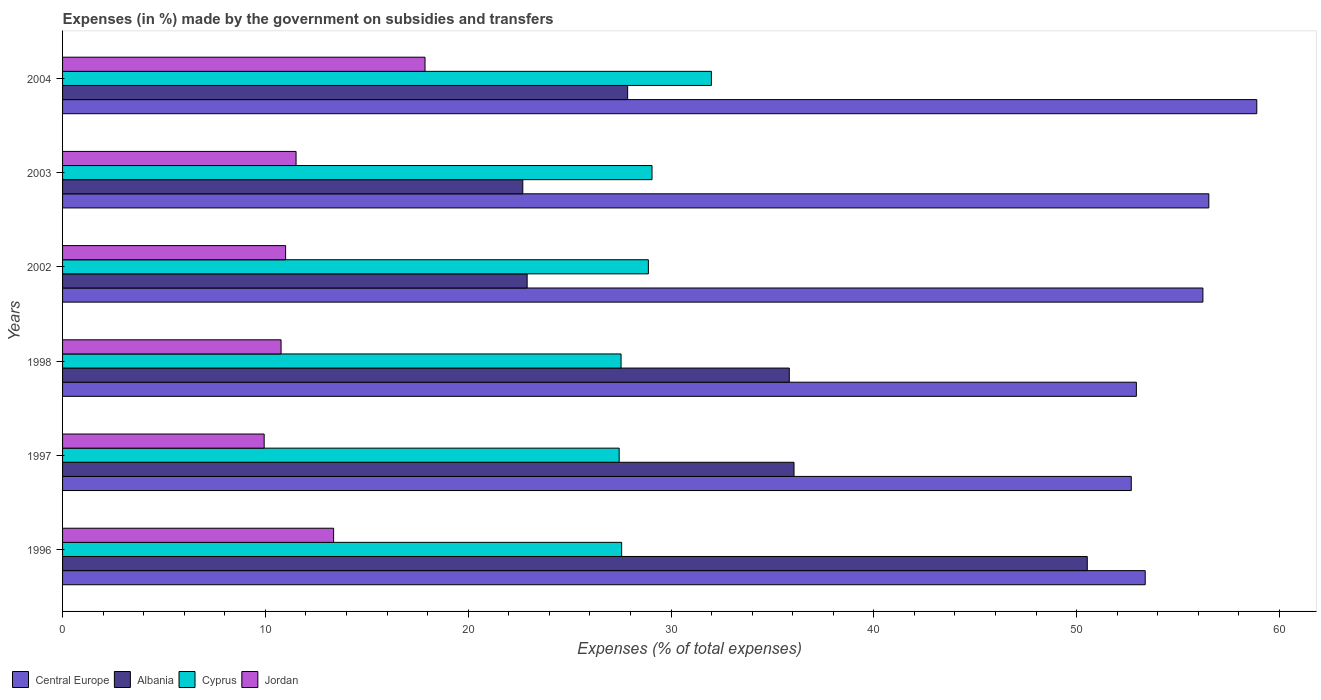How many different coloured bars are there?
Make the answer very short. 4. How many groups of bars are there?
Your answer should be very brief. 6. Are the number of bars on each tick of the Y-axis equal?
Ensure brevity in your answer.  Yes. How many bars are there on the 6th tick from the top?
Make the answer very short. 4. What is the percentage of expenses made by the government on subsidies and transfers in Central Europe in 1996?
Offer a very short reply. 53.38. Across all years, what is the maximum percentage of expenses made by the government on subsidies and transfers in Central Europe?
Make the answer very short. 58.88. Across all years, what is the minimum percentage of expenses made by the government on subsidies and transfers in Central Europe?
Ensure brevity in your answer.  52.69. In which year was the percentage of expenses made by the government on subsidies and transfers in Central Europe minimum?
Make the answer very short. 1997. What is the total percentage of expenses made by the government on subsidies and transfers in Cyprus in the graph?
Ensure brevity in your answer.  172.48. What is the difference between the percentage of expenses made by the government on subsidies and transfers in Albania in 2003 and that in 2004?
Keep it short and to the point. -5.17. What is the difference between the percentage of expenses made by the government on subsidies and transfers in Jordan in 1996 and the percentage of expenses made by the government on subsidies and transfers in Albania in 1997?
Offer a very short reply. -22.7. What is the average percentage of expenses made by the government on subsidies and transfers in Jordan per year?
Your answer should be compact. 12.41. In the year 1998, what is the difference between the percentage of expenses made by the government on subsidies and transfers in Albania and percentage of expenses made by the government on subsidies and transfers in Cyprus?
Offer a terse response. 8.29. In how many years, is the percentage of expenses made by the government on subsidies and transfers in Jordan greater than 54 %?
Keep it short and to the point. 0. What is the ratio of the percentage of expenses made by the government on subsidies and transfers in Jordan in 1996 to that in 1997?
Make the answer very short. 1.34. Is the difference between the percentage of expenses made by the government on subsidies and transfers in Albania in 1996 and 1997 greater than the difference between the percentage of expenses made by the government on subsidies and transfers in Cyprus in 1996 and 1997?
Your response must be concise. Yes. What is the difference between the highest and the second highest percentage of expenses made by the government on subsidies and transfers in Jordan?
Your response must be concise. 4.51. What is the difference between the highest and the lowest percentage of expenses made by the government on subsidies and transfers in Albania?
Keep it short and to the point. 27.83. In how many years, is the percentage of expenses made by the government on subsidies and transfers in Central Europe greater than the average percentage of expenses made by the government on subsidies and transfers in Central Europe taken over all years?
Keep it short and to the point. 3. What does the 1st bar from the top in 2003 represents?
Offer a very short reply. Jordan. What does the 1st bar from the bottom in 1998 represents?
Give a very brief answer. Central Europe. Is it the case that in every year, the sum of the percentage of expenses made by the government on subsidies and transfers in Jordan and percentage of expenses made by the government on subsidies and transfers in Albania is greater than the percentage of expenses made by the government on subsidies and transfers in Central Europe?
Offer a terse response. No. Are all the bars in the graph horizontal?
Provide a succinct answer. Yes. What is the difference between two consecutive major ticks on the X-axis?
Your answer should be very brief. 10. Are the values on the major ticks of X-axis written in scientific E-notation?
Offer a terse response. No. Does the graph contain any zero values?
Provide a short and direct response. No. What is the title of the graph?
Make the answer very short. Expenses (in %) made by the government on subsidies and transfers. What is the label or title of the X-axis?
Make the answer very short. Expenses (% of total expenses). What is the Expenses (% of total expenses) of Central Europe in 1996?
Give a very brief answer. 53.38. What is the Expenses (% of total expenses) in Albania in 1996?
Provide a short and direct response. 50.52. What is the Expenses (% of total expenses) in Cyprus in 1996?
Your answer should be compact. 27.56. What is the Expenses (% of total expenses) of Jordan in 1996?
Provide a succinct answer. 13.36. What is the Expenses (% of total expenses) of Central Europe in 1997?
Your answer should be compact. 52.69. What is the Expenses (% of total expenses) in Albania in 1997?
Keep it short and to the point. 36.06. What is the Expenses (% of total expenses) in Cyprus in 1997?
Your response must be concise. 27.44. What is the Expenses (% of total expenses) in Jordan in 1997?
Keep it short and to the point. 9.94. What is the Expenses (% of total expenses) of Central Europe in 1998?
Your answer should be very brief. 52.94. What is the Expenses (% of total expenses) in Albania in 1998?
Ensure brevity in your answer.  35.83. What is the Expenses (% of total expenses) of Cyprus in 1998?
Ensure brevity in your answer.  27.54. What is the Expenses (% of total expenses) in Jordan in 1998?
Provide a succinct answer. 10.77. What is the Expenses (% of total expenses) of Central Europe in 2002?
Provide a succinct answer. 56.22. What is the Expenses (% of total expenses) in Albania in 2002?
Your answer should be very brief. 22.91. What is the Expenses (% of total expenses) of Cyprus in 2002?
Your response must be concise. 28.88. What is the Expenses (% of total expenses) of Jordan in 2002?
Keep it short and to the point. 11. What is the Expenses (% of total expenses) of Central Europe in 2003?
Your response must be concise. 56.51. What is the Expenses (% of total expenses) in Albania in 2003?
Provide a succinct answer. 22.69. What is the Expenses (% of total expenses) in Cyprus in 2003?
Offer a terse response. 29.06. What is the Expenses (% of total expenses) of Jordan in 2003?
Keep it short and to the point. 11.51. What is the Expenses (% of total expenses) of Central Europe in 2004?
Your answer should be very brief. 58.88. What is the Expenses (% of total expenses) in Albania in 2004?
Give a very brief answer. 27.86. What is the Expenses (% of total expenses) of Cyprus in 2004?
Offer a very short reply. 31.99. What is the Expenses (% of total expenses) of Jordan in 2004?
Provide a short and direct response. 17.87. Across all years, what is the maximum Expenses (% of total expenses) in Central Europe?
Your response must be concise. 58.88. Across all years, what is the maximum Expenses (% of total expenses) of Albania?
Ensure brevity in your answer.  50.52. Across all years, what is the maximum Expenses (% of total expenses) in Cyprus?
Keep it short and to the point. 31.99. Across all years, what is the maximum Expenses (% of total expenses) of Jordan?
Offer a very short reply. 17.87. Across all years, what is the minimum Expenses (% of total expenses) of Central Europe?
Ensure brevity in your answer.  52.69. Across all years, what is the minimum Expenses (% of total expenses) in Albania?
Your response must be concise. 22.69. Across all years, what is the minimum Expenses (% of total expenses) in Cyprus?
Provide a short and direct response. 27.44. Across all years, what is the minimum Expenses (% of total expenses) of Jordan?
Offer a very short reply. 9.94. What is the total Expenses (% of total expenses) in Central Europe in the graph?
Your answer should be very brief. 330.63. What is the total Expenses (% of total expenses) of Albania in the graph?
Offer a terse response. 195.87. What is the total Expenses (% of total expenses) of Cyprus in the graph?
Offer a terse response. 172.48. What is the total Expenses (% of total expenses) in Jordan in the graph?
Provide a short and direct response. 74.46. What is the difference between the Expenses (% of total expenses) of Central Europe in 1996 and that in 1997?
Ensure brevity in your answer.  0.69. What is the difference between the Expenses (% of total expenses) of Albania in 1996 and that in 1997?
Your answer should be compact. 14.46. What is the difference between the Expenses (% of total expenses) of Cyprus in 1996 and that in 1997?
Ensure brevity in your answer.  0.12. What is the difference between the Expenses (% of total expenses) of Jordan in 1996 and that in 1997?
Your answer should be compact. 3.42. What is the difference between the Expenses (% of total expenses) in Central Europe in 1996 and that in 1998?
Give a very brief answer. 0.44. What is the difference between the Expenses (% of total expenses) of Albania in 1996 and that in 1998?
Provide a short and direct response. 14.69. What is the difference between the Expenses (% of total expenses) in Cyprus in 1996 and that in 1998?
Keep it short and to the point. 0.03. What is the difference between the Expenses (% of total expenses) in Jordan in 1996 and that in 1998?
Keep it short and to the point. 2.59. What is the difference between the Expenses (% of total expenses) of Central Europe in 1996 and that in 2002?
Ensure brevity in your answer.  -2.84. What is the difference between the Expenses (% of total expenses) in Albania in 1996 and that in 2002?
Provide a succinct answer. 27.62. What is the difference between the Expenses (% of total expenses) in Cyprus in 1996 and that in 2002?
Offer a terse response. -1.32. What is the difference between the Expenses (% of total expenses) of Jordan in 1996 and that in 2002?
Keep it short and to the point. 2.37. What is the difference between the Expenses (% of total expenses) of Central Europe in 1996 and that in 2003?
Offer a terse response. -3.14. What is the difference between the Expenses (% of total expenses) of Albania in 1996 and that in 2003?
Your answer should be very brief. 27.83. What is the difference between the Expenses (% of total expenses) in Cyprus in 1996 and that in 2003?
Provide a short and direct response. -1.5. What is the difference between the Expenses (% of total expenses) in Jordan in 1996 and that in 2003?
Provide a succinct answer. 1.85. What is the difference between the Expenses (% of total expenses) in Central Europe in 1996 and that in 2004?
Keep it short and to the point. -5.5. What is the difference between the Expenses (% of total expenses) in Albania in 1996 and that in 2004?
Keep it short and to the point. 22.66. What is the difference between the Expenses (% of total expenses) in Cyprus in 1996 and that in 2004?
Your answer should be compact. -4.43. What is the difference between the Expenses (% of total expenses) in Jordan in 1996 and that in 2004?
Make the answer very short. -4.51. What is the difference between the Expenses (% of total expenses) of Central Europe in 1997 and that in 1998?
Your answer should be very brief. -0.25. What is the difference between the Expenses (% of total expenses) in Albania in 1997 and that in 1998?
Provide a short and direct response. 0.23. What is the difference between the Expenses (% of total expenses) in Cyprus in 1997 and that in 1998?
Offer a terse response. -0.09. What is the difference between the Expenses (% of total expenses) in Jordan in 1997 and that in 1998?
Your response must be concise. -0.83. What is the difference between the Expenses (% of total expenses) in Central Europe in 1997 and that in 2002?
Make the answer very short. -3.53. What is the difference between the Expenses (% of total expenses) in Albania in 1997 and that in 2002?
Provide a short and direct response. 13.16. What is the difference between the Expenses (% of total expenses) in Cyprus in 1997 and that in 2002?
Provide a short and direct response. -1.44. What is the difference between the Expenses (% of total expenses) of Jordan in 1997 and that in 2002?
Provide a succinct answer. -1.06. What is the difference between the Expenses (% of total expenses) of Central Europe in 1997 and that in 2003?
Your answer should be very brief. -3.82. What is the difference between the Expenses (% of total expenses) of Albania in 1997 and that in 2003?
Ensure brevity in your answer.  13.37. What is the difference between the Expenses (% of total expenses) in Cyprus in 1997 and that in 2003?
Provide a short and direct response. -1.62. What is the difference between the Expenses (% of total expenses) in Jordan in 1997 and that in 2003?
Give a very brief answer. -1.57. What is the difference between the Expenses (% of total expenses) in Central Europe in 1997 and that in 2004?
Ensure brevity in your answer.  -6.19. What is the difference between the Expenses (% of total expenses) in Albania in 1997 and that in 2004?
Make the answer very short. 8.2. What is the difference between the Expenses (% of total expenses) of Cyprus in 1997 and that in 2004?
Offer a terse response. -4.55. What is the difference between the Expenses (% of total expenses) of Jordan in 1997 and that in 2004?
Your answer should be very brief. -7.93. What is the difference between the Expenses (% of total expenses) of Central Europe in 1998 and that in 2002?
Offer a very short reply. -3.28. What is the difference between the Expenses (% of total expenses) of Albania in 1998 and that in 2002?
Offer a very short reply. 12.92. What is the difference between the Expenses (% of total expenses) in Cyprus in 1998 and that in 2002?
Offer a very short reply. -1.35. What is the difference between the Expenses (% of total expenses) in Jordan in 1998 and that in 2002?
Provide a short and direct response. -0.22. What is the difference between the Expenses (% of total expenses) of Central Europe in 1998 and that in 2003?
Offer a terse response. -3.57. What is the difference between the Expenses (% of total expenses) of Albania in 1998 and that in 2003?
Provide a succinct answer. 13.14. What is the difference between the Expenses (% of total expenses) of Cyprus in 1998 and that in 2003?
Offer a very short reply. -1.53. What is the difference between the Expenses (% of total expenses) of Jordan in 1998 and that in 2003?
Keep it short and to the point. -0.74. What is the difference between the Expenses (% of total expenses) of Central Europe in 1998 and that in 2004?
Provide a short and direct response. -5.94. What is the difference between the Expenses (% of total expenses) of Albania in 1998 and that in 2004?
Make the answer very short. 7.97. What is the difference between the Expenses (% of total expenses) of Cyprus in 1998 and that in 2004?
Give a very brief answer. -4.45. What is the difference between the Expenses (% of total expenses) of Jordan in 1998 and that in 2004?
Make the answer very short. -7.1. What is the difference between the Expenses (% of total expenses) of Central Europe in 2002 and that in 2003?
Your response must be concise. -0.29. What is the difference between the Expenses (% of total expenses) of Albania in 2002 and that in 2003?
Your answer should be very brief. 0.21. What is the difference between the Expenses (% of total expenses) in Cyprus in 2002 and that in 2003?
Make the answer very short. -0.18. What is the difference between the Expenses (% of total expenses) of Jordan in 2002 and that in 2003?
Offer a terse response. -0.52. What is the difference between the Expenses (% of total expenses) in Central Europe in 2002 and that in 2004?
Make the answer very short. -2.66. What is the difference between the Expenses (% of total expenses) in Albania in 2002 and that in 2004?
Your answer should be very brief. -4.96. What is the difference between the Expenses (% of total expenses) of Cyprus in 2002 and that in 2004?
Your response must be concise. -3.11. What is the difference between the Expenses (% of total expenses) in Jordan in 2002 and that in 2004?
Your answer should be very brief. -6.87. What is the difference between the Expenses (% of total expenses) in Central Europe in 2003 and that in 2004?
Keep it short and to the point. -2.36. What is the difference between the Expenses (% of total expenses) in Albania in 2003 and that in 2004?
Keep it short and to the point. -5.17. What is the difference between the Expenses (% of total expenses) of Cyprus in 2003 and that in 2004?
Provide a short and direct response. -2.93. What is the difference between the Expenses (% of total expenses) of Jordan in 2003 and that in 2004?
Your response must be concise. -6.36. What is the difference between the Expenses (% of total expenses) in Central Europe in 1996 and the Expenses (% of total expenses) in Albania in 1997?
Provide a short and direct response. 17.32. What is the difference between the Expenses (% of total expenses) in Central Europe in 1996 and the Expenses (% of total expenses) in Cyprus in 1997?
Give a very brief answer. 25.94. What is the difference between the Expenses (% of total expenses) of Central Europe in 1996 and the Expenses (% of total expenses) of Jordan in 1997?
Give a very brief answer. 43.44. What is the difference between the Expenses (% of total expenses) of Albania in 1996 and the Expenses (% of total expenses) of Cyprus in 1997?
Provide a succinct answer. 23.08. What is the difference between the Expenses (% of total expenses) in Albania in 1996 and the Expenses (% of total expenses) in Jordan in 1997?
Make the answer very short. 40.58. What is the difference between the Expenses (% of total expenses) of Cyprus in 1996 and the Expenses (% of total expenses) of Jordan in 1997?
Provide a succinct answer. 17.62. What is the difference between the Expenses (% of total expenses) in Central Europe in 1996 and the Expenses (% of total expenses) in Albania in 1998?
Provide a short and direct response. 17.55. What is the difference between the Expenses (% of total expenses) of Central Europe in 1996 and the Expenses (% of total expenses) of Cyprus in 1998?
Provide a short and direct response. 25.84. What is the difference between the Expenses (% of total expenses) of Central Europe in 1996 and the Expenses (% of total expenses) of Jordan in 1998?
Give a very brief answer. 42.61. What is the difference between the Expenses (% of total expenses) in Albania in 1996 and the Expenses (% of total expenses) in Cyprus in 1998?
Offer a terse response. 22.99. What is the difference between the Expenses (% of total expenses) in Albania in 1996 and the Expenses (% of total expenses) in Jordan in 1998?
Your response must be concise. 39.75. What is the difference between the Expenses (% of total expenses) in Cyprus in 1996 and the Expenses (% of total expenses) in Jordan in 1998?
Provide a short and direct response. 16.79. What is the difference between the Expenses (% of total expenses) of Central Europe in 1996 and the Expenses (% of total expenses) of Albania in 2002?
Ensure brevity in your answer.  30.47. What is the difference between the Expenses (% of total expenses) of Central Europe in 1996 and the Expenses (% of total expenses) of Cyprus in 2002?
Provide a short and direct response. 24.5. What is the difference between the Expenses (% of total expenses) in Central Europe in 1996 and the Expenses (% of total expenses) in Jordan in 2002?
Your answer should be very brief. 42.38. What is the difference between the Expenses (% of total expenses) in Albania in 1996 and the Expenses (% of total expenses) in Cyprus in 2002?
Make the answer very short. 21.64. What is the difference between the Expenses (% of total expenses) in Albania in 1996 and the Expenses (% of total expenses) in Jordan in 2002?
Give a very brief answer. 39.53. What is the difference between the Expenses (% of total expenses) in Cyprus in 1996 and the Expenses (% of total expenses) in Jordan in 2002?
Your answer should be compact. 16.57. What is the difference between the Expenses (% of total expenses) of Central Europe in 1996 and the Expenses (% of total expenses) of Albania in 2003?
Your response must be concise. 30.69. What is the difference between the Expenses (% of total expenses) of Central Europe in 1996 and the Expenses (% of total expenses) of Cyprus in 2003?
Your answer should be very brief. 24.32. What is the difference between the Expenses (% of total expenses) in Central Europe in 1996 and the Expenses (% of total expenses) in Jordan in 2003?
Your answer should be compact. 41.87. What is the difference between the Expenses (% of total expenses) of Albania in 1996 and the Expenses (% of total expenses) of Cyprus in 2003?
Provide a short and direct response. 21.46. What is the difference between the Expenses (% of total expenses) in Albania in 1996 and the Expenses (% of total expenses) in Jordan in 2003?
Provide a succinct answer. 39.01. What is the difference between the Expenses (% of total expenses) of Cyprus in 1996 and the Expenses (% of total expenses) of Jordan in 2003?
Provide a short and direct response. 16.05. What is the difference between the Expenses (% of total expenses) of Central Europe in 1996 and the Expenses (% of total expenses) of Albania in 2004?
Keep it short and to the point. 25.52. What is the difference between the Expenses (% of total expenses) of Central Europe in 1996 and the Expenses (% of total expenses) of Cyprus in 2004?
Keep it short and to the point. 21.39. What is the difference between the Expenses (% of total expenses) in Central Europe in 1996 and the Expenses (% of total expenses) in Jordan in 2004?
Your answer should be very brief. 35.51. What is the difference between the Expenses (% of total expenses) in Albania in 1996 and the Expenses (% of total expenses) in Cyprus in 2004?
Ensure brevity in your answer.  18.53. What is the difference between the Expenses (% of total expenses) of Albania in 1996 and the Expenses (% of total expenses) of Jordan in 2004?
Give a very brief answer. 32.65. What is the difference between the Expenses (% of total expenses) in Cyprus in 1996 and the Expenses (% of total expenses) in Jordan in 2004?
Your answer should be very brief. 9.69. What is the difference between the Expenses (% of total expenses) in Central Europe in 1997 and the Expenses (% of total expenses) in Albania in 1998?
Your answer should be very brief. 16.86. What is the difference between the Expenses (% of total expenses) of Central Europe in 1997 and the Expenses (% of total expenses) of Cyprus in 1998?
Offer a very short reply. 25.16. What is the difference between the Expenses (% of total expenses) in Central Europe in 1997 and the Expenses (% of total expenses) in Jordan in 1998?
Ensure brevity in your answer.  41.92. What is the difference between the Expenses (% of total expenses) in Albania in 1997 and the Expenses (% of total expenses) in Cyprus in 1998?
Keep it short and to the point. 8.53. What is the difference between the Expenses (% of total expenses) of Albania in 1997 and the Expenses (% of total expenses) of Jordan in 1998?
Make the answer very short. 25.29. What is the difference between the Expenses (% of total expenses) of Cyprus in 1997 and the Expenses (% of total expenses) of Jordan in 1998?
Provide a succinct answer. 16.67. What is the difference between the Expenses (% of total expenses) of Central Europe in 1997 and the Expenses (% of total expenses) of Albania in 2002?
Offer a very short reply. 29.79. What is the difference between the Expenses (% of total expenses) in Central Europe in 1997 and the Expenses (% of total expenses) in Cyprus in 2002?
Provide a succinct answer. 23.81. What is the difference between the Expenses (% of total expenses) of Central Europe in 1997 and the Expenses (% of total expenses) of Jordan in 2002?
Your answer should be compact. 41.69. What is the difference between the Expenses (% of total expenses) in Albania in 1997 and the Expenses (% of total expenses) in Cyprus in 2002?
Keep it short and to the point. 7.18. What is the difference between the Expenses (% of total expenses) in Albania in 1997 and the Expenses (% of total expenses) in Jordan in 2002?
Provide a short and direct response. 25.07. What is the difference between the Expenses (% of total expenses) in Cyprus in 1997 and the Expenses (% of total expenses) in Jordan in 2002?
Ensure brevity in your answer.  16.45. What is the difference between the Expenses (% of total expenses) in Central Europe in 1997 and the Expenses (% of total expenses) in Albania in 2003?
Provide a succinct answer. 30. What is the difference between the Expenses (% of total expenses) of Central Europe in 1997 and the Expenses (% of total expenses) of Cyprus in 2003?
Offer a very short reply. 23.63. What is the difference between the Expenses (% of total expenses) in Central Europe in 1997 and the Expenses (% of total expenses) in Jordan in 2003?
Offer a terse response. 41.18. What is the difference between the Expenses (% of total expenses) in Albania in 1997 and the Expenses (% of total expenses) in Cyprus in 2003?
Give a very brief answer. 7. What is the difference between the Expenses (% of total expenses) of Albania in 1997 and the Expenses (% of total expenses) of Jordan in 2003?
Your response must be concise. 24.55. What is the difference between the Expenses (% of total expenses) of Cyprus in 1997 and the Expenses (% of total expenses) of Jordan in 2003?
Ensure brevity in your answer.  15.93. What is the difference between the Expenses (% of total expenses) of Central Europe in 1997 and the Expenses (% of total expenses) of Albania in 2004?
Make the answer very short. 24.83. What is the difference between the Expenses (% of total expenses) of Central Europe in 1997 and the Expenses (% of total expenses) of Cyprus in 2004?
Offer a very short reply. 20.7. What is the difference between the Expenses (% of total expenses) in Central Europe in 1997 and the Expenses (% of total expenses) in Jordan in 2004?
Your response must be concise. 34.82. What is the difference between the Expenses (% of total expenses) in Albania in 1997 and the Expenses (% of total expenses) in Cyprus in 2004?
Offer a terse response. 4.07. What is the difference between the Expenses (% of total expenses) of Albania in 1997 and the Expenses (% of total expenses) of Jordan in 2004?
Keep it short and to the point. 18.19. What is the difference between the Expenses (% of total expenses) in Cyprus in 1997 and the Expenses (% of total expenses) in Jordan in 2004?
Your answer should be very brief. 9.57. What is the difference between the Expenses (% of total expenses) in Central Europe in 1998 and the Expenses (% of total expenses) in Albania in 2002?
Offer a terse response. 30.04. What is the difference between the Expenses (% of total expenses) of Central Europe in 1998 and the Expenses (% of total expenses) of Cyprus in 2002?
Keep it short and to the point. 24.06. What is the difference between the Expenses (% of total expenses) in Central Europe in 1998 and the Expenses (% of total expenses) in Jordan in 2002?
Ensure brevity in your answer.  41.95. What is the difference between the Expenses (% of total expenses) in Albania in 1998 and the Expenses (% of total expenses) in Cyprus in 2002?
Keep it short and to the point. 6.95. What is the difference between the Expenses (% of total expenses) of Albania in 1998 and the Expenses (% of total expenses) of Jordan in 2002?
Make the answer very short. 24.83. What is the difference between the Expenses (% of total expenses) of Cyprus in 1998 and the Expenses (% of total expenses) of Jordan in 2002?
Provide a short and direct response. 16.54. What is the difference between the Expenses (% of total expenses) in Central Europe in 1998 and the Expenses (% of total expenses) in Albania in 2003?
Your answer should be compact. 30.25. What is the difference between the Expenses (% of total expenses) of Central Europe in 1998 and the Expenses (% of total expenses) of Cyprus in 2003?
Your answer should be compact. 23.88. What is the difference between the Expenses (% of total expenses) in Central Europe in 1998 and the Expenses (% of total expenses) in Jordan in 2003?
Your response must be concise. 41.43. What is the difference between the Expenses (% of total expenses) in Albania in 1998 and the Expenses (% of total expenses) in Cyprus in 2003?
Your answer should be very brief. 6.77. What is the difference between the Expenses (% of total expenses) in Albania in 1998 and the Expenses (% of total expenses) in Jordan in 2003?
Offer a terse response. 24.32. What is the difference between the Expenses (% of total expenses) in Cyprus in 1998 and the Expenses (% of total expenses) in Jordan in 2003?
Make the answer very short. 16.02. What is the difference between the Expenses (% of total expenses) in Central Europe in 1998 and the Expenses (% of total expenses) in Albania in 2004?
Ensure brevity in your answer.  25.08. What is the difference between the Expenses (% of total expenses) of Central Europe in 1998 and the Expenses (% of total expenses) of Cyprus in 2004?
Your answer should be very brief. 20.95. What is the difference between the Expenses (% of total expenses) of Central Europe in 1998 and the Expenses (% of total expenses) of Jordan in 2004?
Make the answer very short. 35.07. What is the difference between the Expenses (% of total expenses) in Albania in 1998 and the Expenses (% of total expenses) in Cyprus in 2004?
Offer a terse response. 3.84. What is the difference between the Expenses (% of total expenses) in Albania in 1998 and the Expenses (% of total expenses) in Jordan in 2004?
Your answer should be very brief. 17.96. What is the difference between the Expenses (% of total expenses) of Cyprus in 1998 and the Expenses (% of total expenses) of Jordan in 2004?
Keep it short and to the point. 9.66. What is the difference between the Expenses (% of total expenses) in Central Europe in 2002 and the Expenses (% of total expenses) in Albania in 2003?
Give a very brief answer. 33.53. What is the difference between the Expenses (% of total expenses) of Central Europe in 2002 and the Expenses (% of total expenses) of Cyprus in 2003?
Offer a terse response. 27.16. What is the difference between the Expenses (% of total expenses) of Central Europe in 2002 and the Expenses (% of total expenses) of Jordan in 2003?
Keep it short and to the point. 44.71. What is the difference between the Expenses (% of total expenses) in Albania in 2002 and the Expenses (% of total expenses) in Cyprus in 2003?
Ensure brevity in your answer.  -6.16. What is the difference between the Expenses (% of total expenses) of Albania in 2002 and the Expenses (% of total expenses) of Jordan in 2003?
Your answer should be compact. 11.39. What is the difference between the Expenses (% of total expenses) in Cyprus in 2002 and the Expenses (% of total expenses) in Jordan in 2003?
Your answer should be compact. 17.37. What is the difference between the Expenses (% of total expenses) in Central Europe in 2002 and the Expenses (% of total expenses) in Albania in 2004?
Your response must be concise. 28.36. What is the difference between the Expenses (% of total expenses) of Central Europe in 2002 and the Expenses (% of total expenses) of Cyprus in 2004?
Provide a short and direct response. 24.23. What is the difference between the Expenses (% of total expenses) of Central Europe in 2002 and the Expenses (% of total expenses) of Jordan in 2004?
Ensure brevity in your answer.  38.35. What is the difference between the Expenses (% of total expenses) in Albania in 2002 and the Expenses (% of total expenses) in Cyprus in 2004?
Ensure brevity in your answer.  -9.08. What is the difference between the Expenses (% of total expenses) of Albania in 2002 and the Expenses (% of total expenses) of Jordan in 2004?
Your response must be concise. 5.03. What is the difference between the Expenses (% of total expenses) of Cyprus in 2002 and the Expenses (% of total expenses) of Jordan in 2004?
Make the answer very short. 11.01. What is the difference between the Expenses (% of total expenses) in Central Europe in 2003 and the Expenses (% of total expenses) in Albania in 2004?
Offer a terse response. 28.65. What is the difference between the Expenses (% of total expenses) in Central Europe in 2003 and the Expenses (% of total expenses) in Cyprus in 2004?
Make the answer very short. 24.52. What is the difference between the Expenses (% of total expenses) of Central Europe in 2003 and the Expenses (% of total expenses) of Jordan in 2004?
Make the answer very short. 38.64. What is the difference between the Expenses (% of total expenses) of Albania in 2003 and the Expenses (% of total expenses) of Cyprus in 2004?
Your answer should be compact. -9.3. What is the difference between the Expenses (% of total expenses) in Albania in 2003 and the Expenses (% of total expenses) in Jordan in 2004?
Your answer should be very brief. 4.82. What is the difference between the Expenses (% of total expenses) of Cyprus in 2003 and the Expenses (% of total expenses) of Jordan in 2004?
Your answer should be compact. 11.19. What is the average Expenses (% of total expenses) in Central Europe per year?
Make the answer very short. 55.11. What is the average Expenses (% of total expenses) of Albania per year?
Offer a very short reply. 32.65. What is the average Expenses (% of total expenses) in Cyprus per year?
Keep it short and to the point. 28.75. What is the average Expenses (% of total expenses) in Jordan per year?
Keep it short and to the point. 12.41. In the year 1996, what is the difference between the Expenses (% of total expenses) of Central Europe and Expenses (% of total expenses) of Albania?
Offer a terse response. 2.86. In the year 1996, what is the difference between the Expenses (% of total expenses) of Central Europe and Expenses (% of total expenses) of Cyprus?
Offer a terse response. 25.81. In the year 1996, what is the difference between the Expenses (% of total expenses) in Central Europe and Expenses (% of total expenses) in Jordan?
Offer a very short reply. 40.02. In the year 1996, what is the difference between the Expenses (% of total expenses) of Albania and Expenses (% of total expenses) of Cyprus?
Your answer should be compact. 22.96. In the year 1996, what is the difference between the Expenses (% of total expenses) in Albania and Expenses (% of total expenses) in Jordan?
Offer a terse response. 37.16. In the year 1996, what is the difference between the Expenses (% of total expenses) in Cyprus and Expenses (% of total expenses) in Jordan?
Offer a terse response. 14.2. In the year 1997, what is the difference between the Expenses (% of total expenses) of Central Europe and Expenses (% of total expenses) of Albania?
Keep it short and to the point. 16.63. In the year 1997, what is the difference between the Expenses (% of total expenses) in Central Europe and Expenses (% of total expenses) in Cyprus?
Your answer should be very brief. 25.25. In the year 1997, what is the difference between the Expenses (% of total expenses) of Central Europe and Expenses (% of total expenses) of Jordan?
Your answer should be very brief. 42.75. In the year 1997, what is the difference between the Expenses (% of total expenses) of Albania and Expenses (% of total expenses) of Cyprus?
Provide a short and direct response. 8.62. In the year 1997, what is the difference between the Expenses (% of total expenses) in Albania and Expenses (% of total expenses) in Jordan?
Offer a very short reply. 26.12. In the year 1997, what is the difference between the Expenses (% of total expenses) in Cyprus and Expenses (% of total expenses) in Jordan?
Ensure brevity in your answer.  17.5. In the year 1998, what is the difference between the Expenses (% of total expenses) in Central Europe and Expenses (% of total expenses) in Albania?
Your answer should be very brief. 17.11. In the year 1998, what is the difference between the Expenses (% of total expenses) in Central Europe and Expenses (% of total expenses) in Cyprus?
Give a very brief answer. 25.41. In the year 1998, what is the difference between the Expenses (% of total expenses) in Central Europe and Expenses (% of total expenses) in Jordan?
Ensure brevity in your answer.  42.17. In the year 1998, what is the difference between the Expenses (% of total expenses) of Albania and Expenses (% of total expenses) of Cyprus?
Ensure brevity in your answer.  8.29. In the year 1998, what is the difference between the Expenses (% of total expenses) of Albania and Expenses (% of total expenses) of Jordan?
Provide a succinct answer. 25.06. In the year 1998, what is the difference between the Expenses (% of total expenses) of Cyprus and Expenses (% of total expenses) of Jordan?
Your response must be concise. 16.76. In the year 2002, what is the difference between the Expenses (% of total expenses) in Central Europe and Expenses (% of total expenses) in Albania?
Keep it short and to the point. 33.32. In the year 2002, what is the difference between the Expenses (% of total expenses) in Central Europe and Expenses (% of total expenses) in Cyprus?
Offer a terse response. 27.34. In the year 2002, what is the difference between the Expenses (% of total expenses) of Central Europe and Expenses (% of total expenses) of Jordan?
Give a very brief answer. 45.23. In the year 2002, what is the difference between the Expenses (% of total expenses) of Albania and Expenses (% of total expenses) of Cyprus?
Give a very brief answer. -5.98. In the year 2002, what is the difference between the Expenses (% of total expenses) in Albania and Expenses (% of total expenses) in Jordan?
Ensure brevity in your answer.  11.91. In the year 2002, what is the difference between the Expenses (% of total expenses) in Cyprus and Expenses (% of total expenses) in Jordan?
Provide a succinct answer. 17.89. In the year 2003, what is the difference between the Expenses (% of total expenses) in Central Europe and Expenses (% of total expenses) in Albania?
Offer a very short reply. 33.82. In the year 2003, what is the difference between the Expenses (% of total expenses) in Central Europe and Expenses (% of total expenses) in Cyprus?
Provide a succinct answer. 27.45. In the year 2003, what is the difference between the Expenses (% of total expenses) of Central Europe and Expenses (% of total expenses) of Jordan?
Your answer should be compact. 45. In the year 2003, what is the difference between the Expenses (% of total expenses) of Albania and Expenses (% of total expenses) of Cyprus?
Offer a terse response. -6.37. In the year 2003, what is the difference between the Expenses (% of total expenses) of Albania and Expenses (% of total expenses) of Jordan?
Your answer should be very brief. 11.18. In the year 2003, what is the difference between the Expenses (% of total expenses) of Cyprus and Expenses (% of total expenses) of Jordan?
Offer a very short reply. 17.55. In the year 2004, what is the difference between the Expenses (% of total expenses) of Central Europe and Expenses (% of total expenses) of Albania?
Offer a terse response. 31.02. In the year 2004, what is the difference between the Expenses (% of total expenses) of Central Europe and Expenses (% of total expenses) of Cyprus?
Your answer should be very brief. 26.89. In the year 2004, what is the difference between the Expenses (% of total expenses) of Central Europe and Expenses (% of total expenses) of Jordan?
Your response must be concise. 41.01. In the year 2004, what is the difference between the Expenses (% of total expenses) of Albania and Expenses (% of total expenses) of Cyprus?
Make the answer very short. -4.13. In the year 2004, what is the difference between the Expenses (% of total expenses) of Albania and Expenses (% of total expenses) of Jordan?
Keep it short and to the point. 9.99. In the year 2004, what is the difference between the Expenses (% of total expenses) of Cyprus and Expenses (% of total expenses) of Jordan?
Keep it short and to the point. 14.12. What is the ratio of the Expenses (% of total expenses) in Albania in 1996 to that in 1997?
Provide a succinct answer. 1.4. What is the ratio of the Expenses (% of total expenses) of Jordan in 1996 to that in 1997?
Make the answer very short. 1.34. What is the ratio of the Expenses (% of total expenses) in Central Europe in 1996 to that in 1998?
Offer a terse response. 1.01. What is the ratio of the Expenses (% of total expenses) in Albania in 1996 to that in 1998?
Your answer should be very brief. 1.41. What is the ratio of the Expenses (% of total expenses) in Jordan in 1996 to that in 1998?
Your answer should be very brief. 1.24. What is the ratio of the Expenses (% of total expenses) in Central Europe in 1996 to that in 2002?
Provide a short and direct response. 0.95. What is the ratio of the Expenses (% of total expenses) in Albania in 1996 to that in 2002?
Offer a very short reply. 2.21. What is the ratio of the Expenses (% of total expenses) of Cyprus in 1996 to that in 2002?
Keep it short and to the point. 0.95. What is the ratio of the Expenses (% of total expenses) of Jordan in 1996 to that in 2002?
Your answer should be compact. 1.22. What is the ratio of the Expenses (% of total expenses) of Central Europe in 1996 to that in 2003?
Offer a very short reply. 0.94. What is the ratio of the Expenses (% of total expenses) in Albania in 1996 to that in 2003?
Your answer should be very brief. 2.23. What is the ratio of the Expenses (% of total expenses) of Cyprus in 1996 to that in 2003?
Give a very brief answer. 0.95. What is the ratio of the Expenses (% of total expenses) in Jordan in 1996 to that in 2003?
Ensure brevity in your answer.  1.16. What is the ratio of the Expenses (% of total expenses) of Central Europe in 1996 to that in 2004?
Offer a very short reply. 0.91. What is the ratio of the Expenses (% of total expenses) of Albania in 1996 to that in 2004?
Offer a terse response. 1.81. What is the ratio of the Expenses (% of total expenses) in Cyprus in 1996 to that in 2004?
Keep it short and to the point. 0.86. What is the ratio of the Expenses (% of total expenses) of Jordan in 1996 to that in 2004?
Your answer should be very brief. 0.75. What is the ratio of the Expenses (% of total expenses) of Central Europe in 1997 to that in 1998?
Give a very brief answer. 1. What is the ratio of the Expenses (% of total expenses) of Albania in 1997 to that in 1998?
Ensure brevity in your answer.  1.01. What is the ratio of the Expenses (% of total expenses) in Cyprus in 1997 to that in 1998?
Offer a very short reply. 1. What is the ratio of the Expenses (% of total expenses) of Jordan in 1997 to that in 1998?
Provide a succinct answer. 0.92. What is the ratio of the Expenses (% of total expenses) in Central Europe in 1997 to that in 2002?
Provide a short and direct response. 0.94. What is the ratio of the Expenses (% of total expenses) of Albania in 1997 to that in 2002?
Provide a short and direct response. 1.57. What is the ratio of the Expenses (% of total expenses) in Cyprus in 1997 to that in 2002?
Your response must be concise. 0.95. What is the ratio of the Expenses (% of total expenses) in Jordan in 1997 to that in 2002?
Offer a very short reply. 0.9. What is the ratio of the Expenses (% of total expenses) of Central Europe in 1997 to that in 2003?
Keep it short and to the point. 0.93. What is the ratio of the Expenses (% of total expenses) in Albania in 1997 to that in 2003?
Offer a terse response. 1.59. What is the ratio of the Expenses (% of total expenses) in Cyprus in 1997 to that in 2003?
Provide a short and direct response. 0.94. What is the ratio of the Expenses (% of total expenses) of Jordan in 1997 to that in 2003?
Make the answer very short. 0.86. What is the ratio of the Expenses (% of total expenses) in Central Europe in 1997 to that in 2004?
Give a very brief answer. 0.89. What is the ratio of the Expenses (% of total expenses) in Albania in 1997 to that in 2004?
Make the answer very short. 1.29. What is the ratio of the Expenses (% of total expenses) of Cyprus in 1997 to that in 2004?
Keep it short and to the point. 0.86. What is the ratio of the Expenses (% of total expenses) in Jordan in 1997 to that in 2004?
Keep it short and to the point. 0.56. What is the ratio of the Expenses (% of total expenses) in Central Europe in 1998 to that in 2002?
Ensure brevity in your answer.  0.94. What is the ratio of the Expenses (% of total expenses) of Albania in 1998 to that in 2002?
Your answer should be compact. 1.56. What is the ratio of the Expenses (% of total expenses) of Cyprus in 1998 to that in 2002?
Ensure brevity in your answer.  0.95. What is the ratio of the Expenses (% of total expenses) of Jordan in 1998 to that in 2002?
Give a very brief answer. 0.98. What is the ratio of the Expenses (% of total expenses) of Central Europe in 1998 to that in 2003?
Offer a very short reply. 0.94. What is the ratio of the Expenses (% of total expenses) in Albania in 1998 to that in 2003?
Keep it short and to the point. 1.58. What is the ratio of the Expenses (% of total expenses) of Cyprus in 1998 to that in 2003?
Your response must be concise. 0.95. What is the ratio of the Expenses (% of total expenses) in Jordan in 1998 to that in 2003?
Your response must be concise. 0.94. What is the ratio of the Expenses (% of total expenses) in Central Europe in 1998 to that in 2004?
Your response must be concise. 0.9. What is the ratio of the Expenses (% of total expenses) in Albania in 1998 to that in 2004?
Make the answer very short. 1.29. What is the ratio of the Expenses (% of total expenses) in Cyprus in 1998 to that in 2004?
Offer a terse response. 0.86. What is the ratio of the Expenses (% of total expenses) of Jordan in 1998 to that in 2004?
Give a very brief answer. 0.6. What is the ratio of the Expenses (% of total expenses) of Albania in 2002 to that in 2003?
Your answer should be compact. 1.01. What is the ratio of the Expenses (% of total expenses) in Cyprus in 2002 to that in 2003?
Make the answer very short. 0.99. What is the ratio of the Expenses (% of total expenses) of Jordan in 2002 to that in 2003?
Your answer should be compact. 0.96. What is the ratio of the Expenses (% of total expenses) in Central Europe in 2002 to that in 2004?
Give a very brief answer. 0.95. What is the ratio of the Expenses (% of total expenses) in Albania in 2002 to that in 2004?
Your answer should be compact. 0.82. What is the ratio of the Expenses (% of total expenses) of Cyprus in 2002 to that in 2004?
Your answer should be very brief. 0.9. What is the ratio of the Expenses (% of total expenses) of Jordan in 2002 to that in 2004?
Offer a very short reply. 0.62. What is the ratio of the Expenses (% of total expenses) in Central Europe in 2003 to that in 2004?
Your answer should be compact. 0.96. What is the ratio of the Expenses (% of total expenses) in Albania in 2003 to that in 2004?
Your answer should be very brief. 0.81. What is the ratio of the Expenses (% of total expenses) in Cyprus in 2003 to that in 2004?
Your response must be concise. 0.91. What is the ratio of the Expenses (% of total expenses) in Jordan in 2003 to that in 2004?
Your answer should be compact. 0.64. What is the difference between the highest and the second highest Expenses (% of total expenses) in Central Europe?
Your answer should be compact. 2.36. What is the difference between the highest and the second highest Expenses (% of total expenses) of Albania?
Provide a short and direct response. 14.46. What is the difference between the highest and the second highest Expenses (% of total expenses) of Cyprus?
Your answer should be compact. 2.93. What is the difference between the highest and the second highest Expenses (% of total expenses) of Jordan?
Provide a succinct answer. 4.51. What is the difference between the highest and the lowest Expenses (% of total expenses) in Central Europe?
Provide a succinct answer. 6.19. What is the difference between the highest and the lowest Expenses (% of total expenses) in Albania?
Your answer should be compact. 27.83. What is the difference between the highest and the lowest Expenses (% of total expenses) in Cyprus?
Provide a succinct answer. 4.55. What is the difference between the highest and the lowest Expenses (% of total expenses) in Jordan?
Provide a succinct answer. 7.93. 